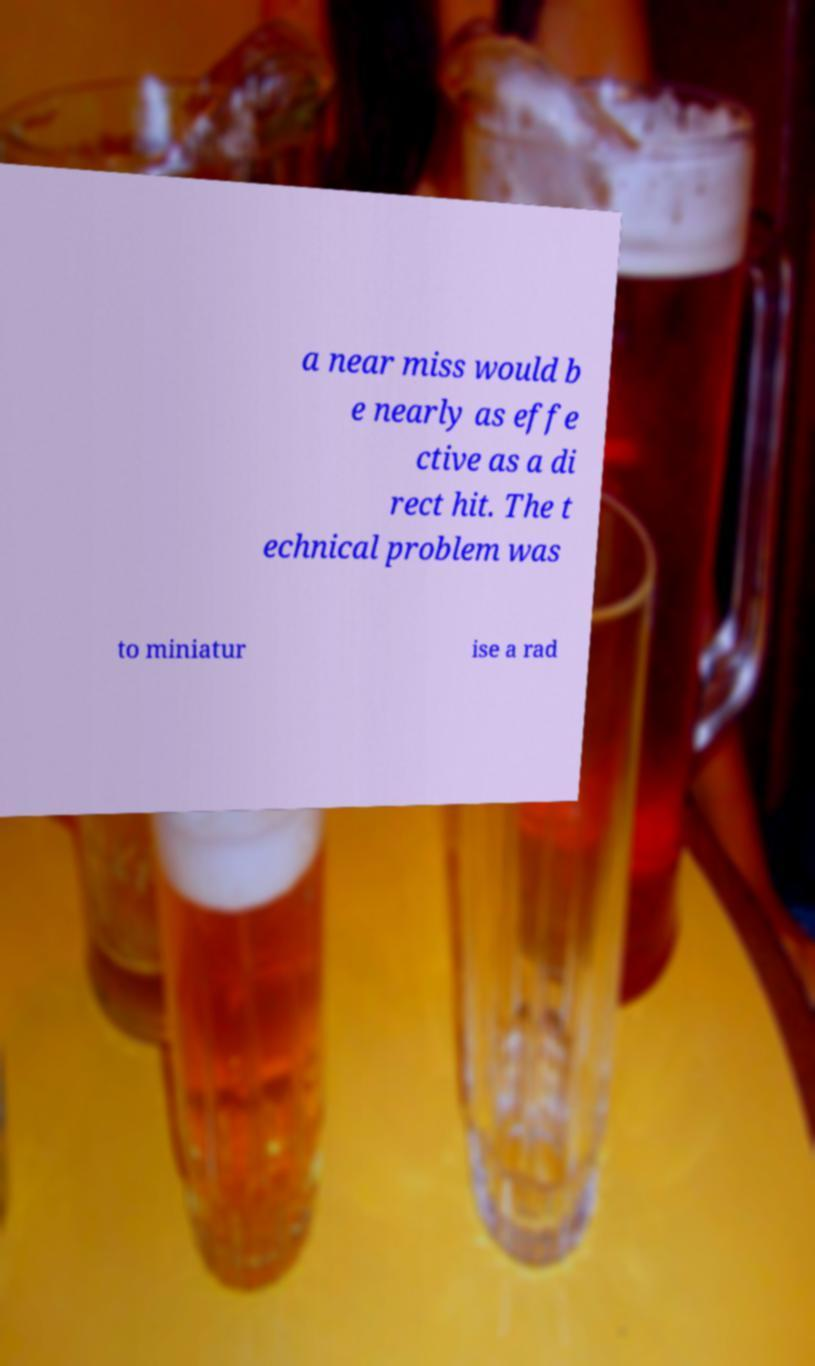I need the written content from this picture converted into text. Can you do that? a near miss would b e nearly as effe ctive as a di rect hit. The t echnical problem was to miniatur ise a rad 